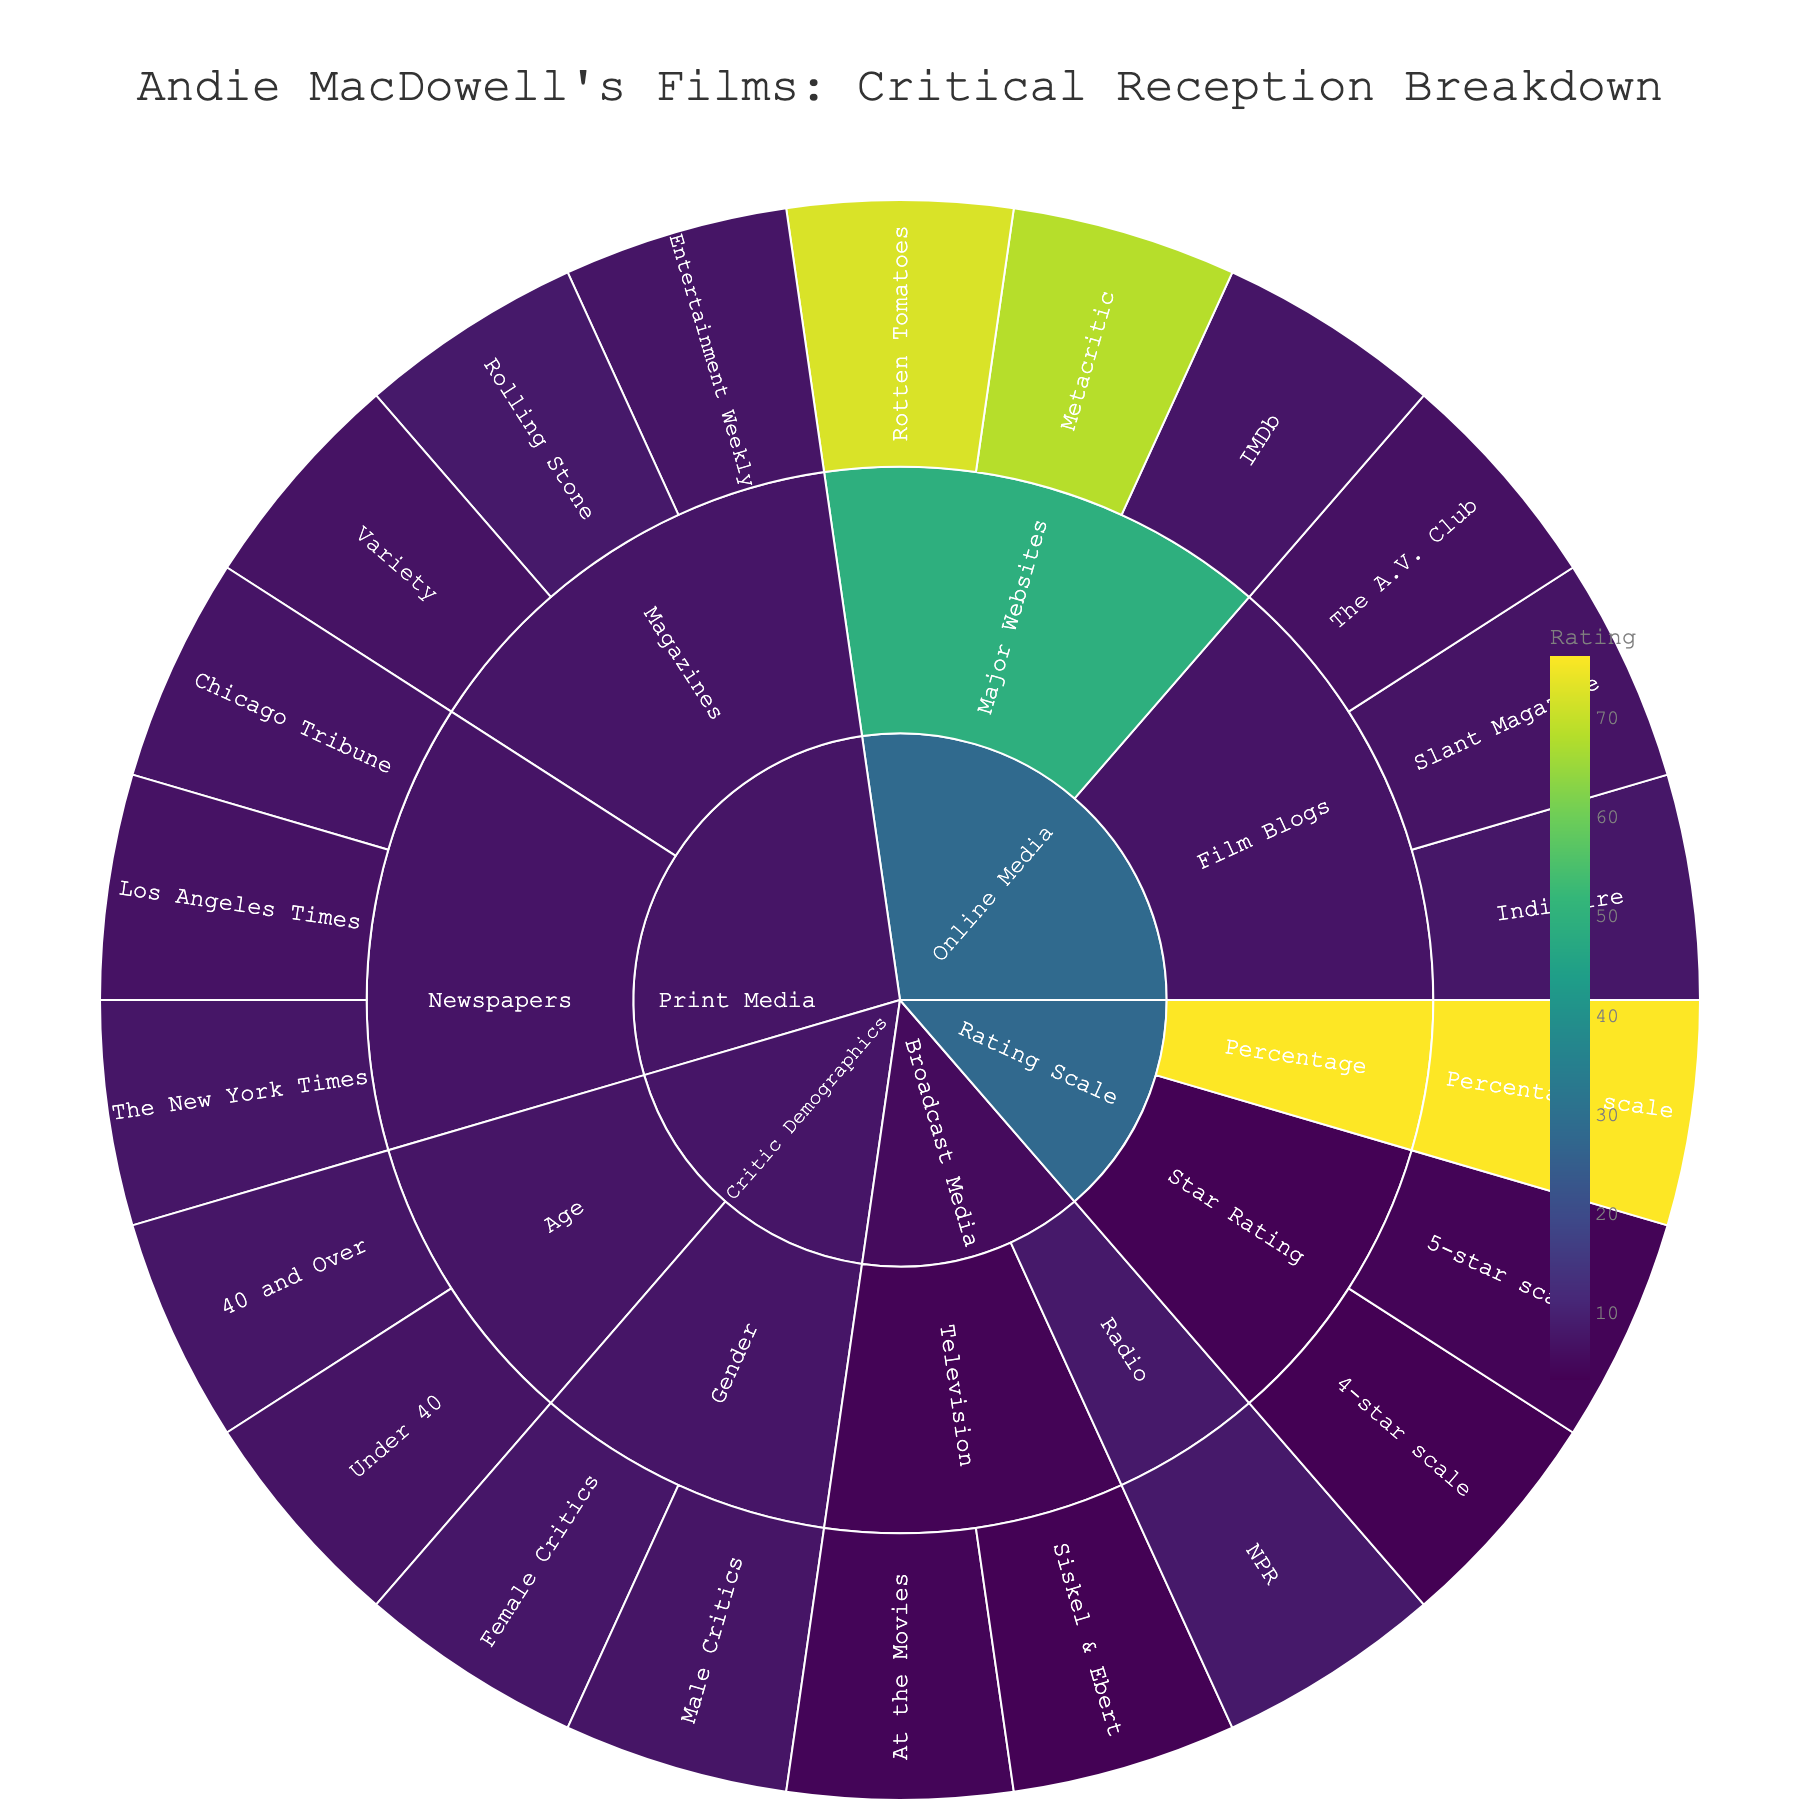What's the title of the figure? The title is positioned at the top center of the sunburst plot and it reads "Andie MacDowell's Films: Critical Reception Breakdown".
Answer: Andie MacDowell's Films: Critical Reception Breakdown Which publication under Print Media has the highest rating? Under the Print Media category, the publication with the highest rating as indicated by the shade of color on the plot is Rolling Stone with a rating of 8.1.
Answer: Rolling Stone What are the average ratings of male and female critics? Under Critic Demographics→Gender, male critics have a rating of 7.3 and female critics have a rating of 7.6. To find the average, sum the ratings (7.3 + 7.6) and divide by 2. (7.3 + 7.6) / 2 = 7.45
Answer: 7.45 Which subcategory under Online Media has the most entries? The Online Media category has two subcategories: Major Websites and Film Blogs. By counting the entries in each, Major Websites has 3 entries (Rotten Tomatoes, Metacritic, IMDb) and Film Blogs has 3 entries (IndieWire, The A.V. Club, Slant Magazine). Both have the same number of entries.
Answer: Both have the same number Which subcategory under Broadcast Media has the lowest rating? The subcategory with the lowest rating under Broadcast Media is Television, with Siskel & Ebert having a rating of 3.5.
Answer: Television What is the overall trend in ratings between male versus female critics? Comparing the ratings of male and female critics, female critics have a slightly higher average rating (7.6) compared to male critics (7.3).
Answer: Female critics rate higher Between Rotten Tomatoes and Metacritic, which has a higher rating? By comparing the two data points under Online Media→Major Websites, Rotten Tomatoes has a rating of 72 which is higher than Metacritic's rating of 68.
Answer: Rotten Tomatoes How does the rating from NPR compare to other Broadcast Media ratings? NPR, categorized under Broadcast Media→Radio, has a rating of 8.2. By comparing to Television and Radio subcategories under Broadcast Media, NPR has the highest rating in this category.
Answer: NPR has the highest rating 